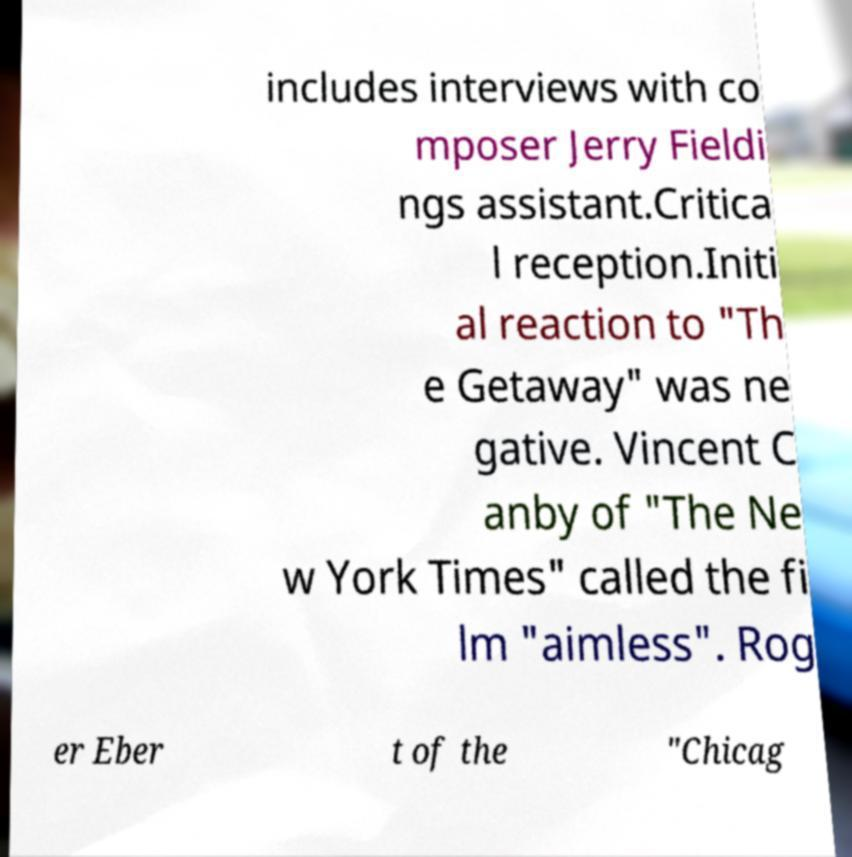Could you assist in decoding the text presented in this image and type it out clearly? includes interviews with co mposer Jerry Fieldi ngs assistant.Critica l reception.Initi al reaction to "Th e Getaway" was ne gative. Vincent C anby of "The Ne w York Times" called the fi lm "aimless". Rog er Eber t of the "Chicag 